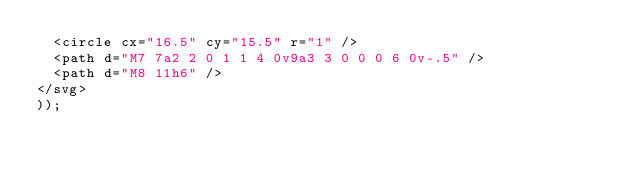<code> <loc_0><loc_0><loc_500><loc_500><_JavaScript_>  <circle cx="16.5" cy="15.5" r="1" />
  <path d="M7 7a2 2 0 1 1 4 0v9a3 3 0 0 0 6 0v-.5" />
  <path d="M8 11h6" />
</svg>
));
</code> 